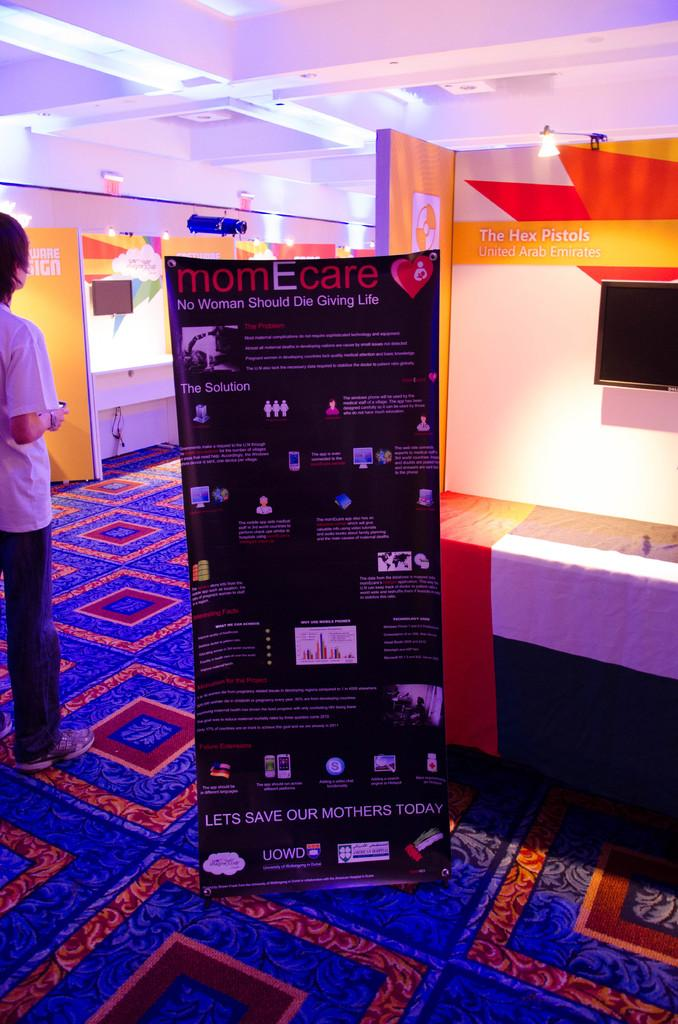What is the main subject in the image? There is a person standing in the image. Where is the person standing? The person is standing on the floor. What else can be seen in the image besides the person? There is an advertisement board and a television screen in the image. What type of flooring is present in the image? There is a carpet in the image. What type of garden can be seen in the frame of the image? There is no garden present in the image, nor is there a frame around the image. 